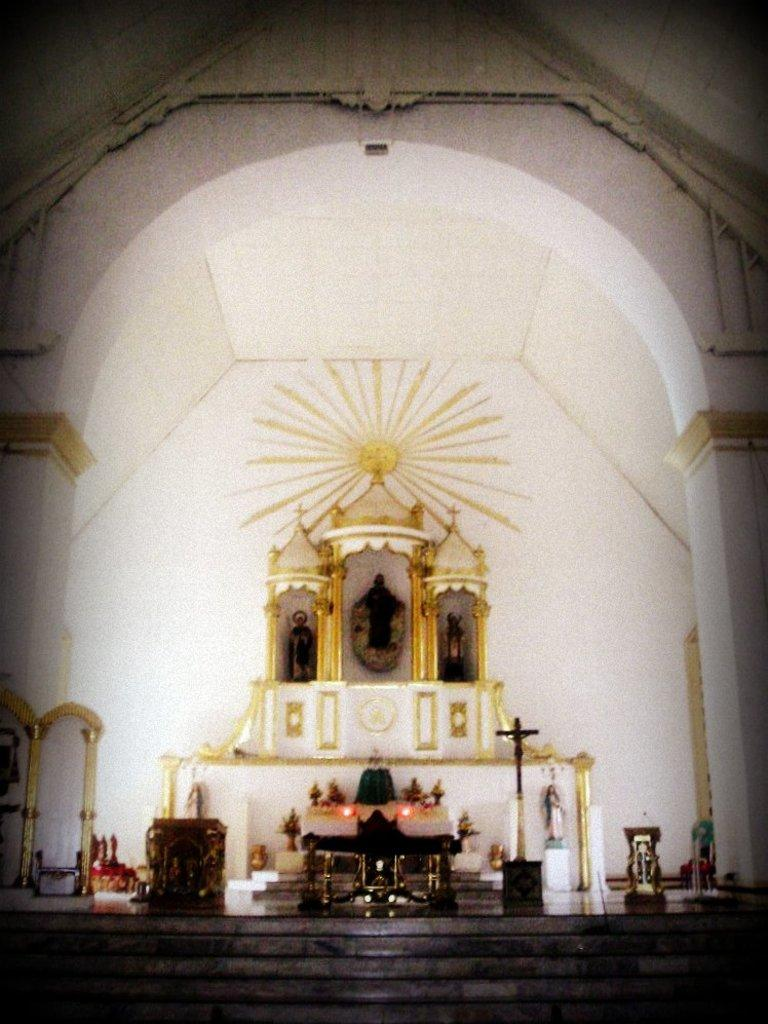What type of building is depicted in the image? The image is of the inside of a church. What architectural feature can be seen in the image? There is an arch in the image. What is another feature that can be seen in the image? There is a staircase in the image. What type of artwork is present in the image? There are sculptures in the image. What religious symbol is visible in the image? The holy cross symbol is present in the image. What type of furniture is in the image? There is a table and chairs in the image. What decorative items can be seen in the image? Flower bouquets are visible in the image. Are there any other items in the image? Yes, there are other items in the image. What type of drink is being served in the image? There is no drink visible in the image. What type of music is being played in the image? There is no music or record player present in the image. 